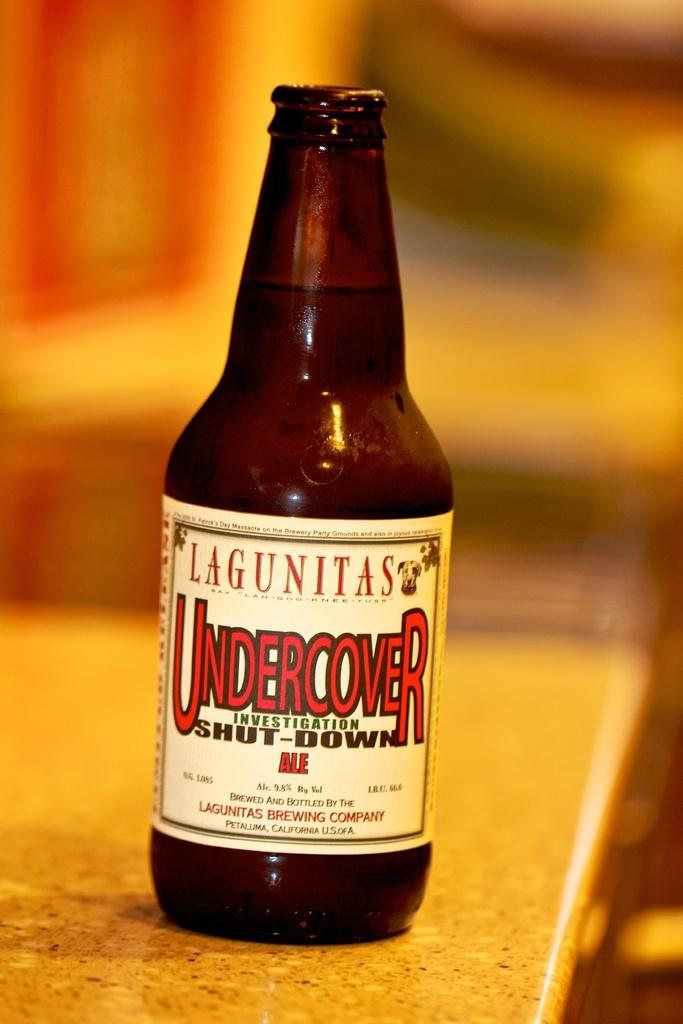<image>
Share a concise interpretation of the image provided. Bottle of beer called Undercover Investigation Shut-Down Ale on top of a wooden surface. 